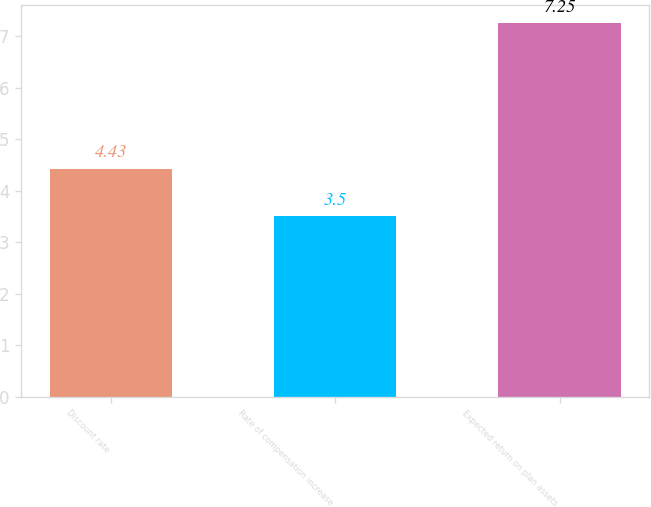Convert chart. <chart><loc_0><loc_0><loc_500><loc_500><bar_chart><fcel>Discount rate<fcel>Rate of compensation increase<fcel>Expected return on plan assets<nl><fcel>4.43<fcel>3.5<fcel>7.25<nl></chart> 